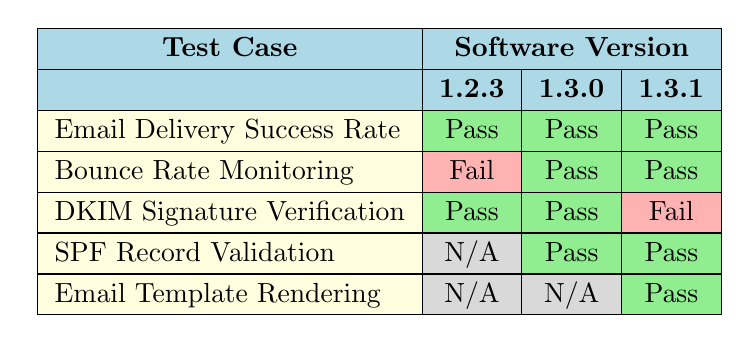What is the execution result of the "Bounce Rate Monitoring" test case for software version 1.2.3? The table shows the execution result of the "Bounce Rate Monitoring" test case for version 1.2.3, which is highlighted in red and labeled as "Fail."
Answer: Fail How many test cases executed successfully for software version 1.3.0? In the table under software version 1.3.0, there are three test cases. Out of those, two test cases ("Bounce Rate Monitoring" and "DKIM Signature Verification") passed while one test case ("SPF Record Validation") has passed too, making a total of three successful cases.
Answer: 3 Did the "Email Delivery Success Rate" test case ever fail? Referring to the table, the "Email Delivery Success Rate" test case shows a passing result across all software versions listed, indicating that it never failed.
Answer: No What is the highest execution time recorded for the "DKIM Signature Verification" test case? The table shows three execution times for the "DKIM Signature Verification." They are 30 minutes for version 1.2.3, 35 minutes for version 1.3.0, and 40 minutes for version 1.3.1. The highest of these values is 40 minutes.
Answer: 40 Which test case experienced a failure in the latest software version (1.3.1)? In the table, when examining version 1.3.1, the "DKIM Signature Verification" test case is the only one that shows a failing result, while others passed.
Answer: DKIM Signature Verification What is the total number of test cases evaluated across all software versions? There are five unique test cases listed in the table: "Email Delivery Success Rate," "Bounce Rate Monitoring," "DKIM Signature Verification," "SPF Record Validation," and "Email Template Rendering." Thus, the total number of evaluated test cases is five.
Answer: 5 For which software version did "SPF Record Validation" get its first execution? Looking at the table, "SPF Record Validation" has its first recorded execution for version 1.3.0, indicated by its presence without an entry for 1.2.3.
Answer: 1.3.0 How many test cases had "Pass" results for all software versions they were executed in? By checking each test case throughout the table, we find that "Email Delivery Success Rate," "Bounce Rate Monitoring," and "SPF Record Validation" recorded "Pass" results for every version except "Bounce Rate Monitoring" for 1.2.3, leading to a total of two test cases that had all "Pass" results across versions: "Email Delivery Success Rate" and "SPF Record Validation."
Answer: 2 